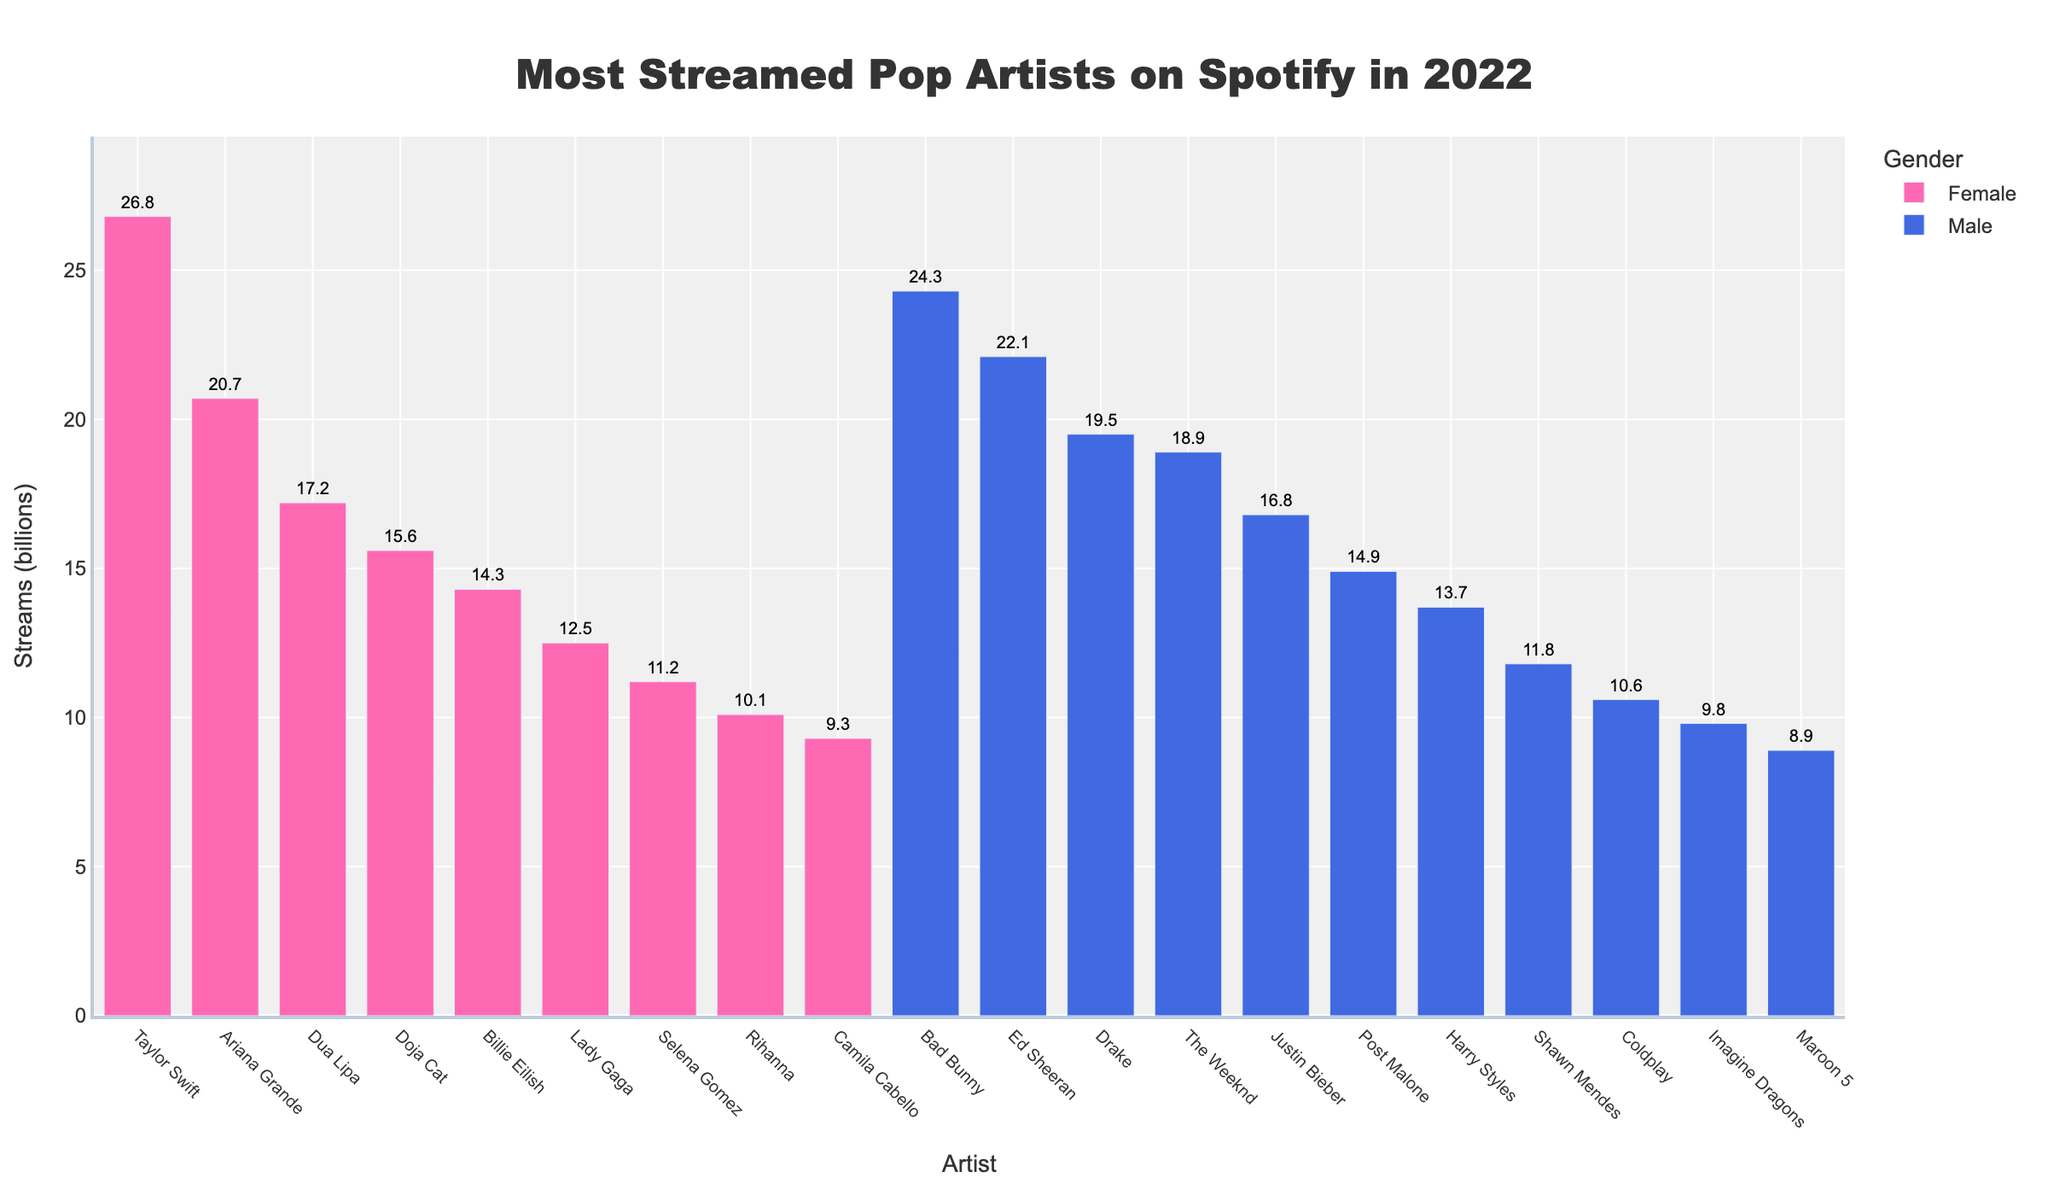Who is the most streamed pop artist on Spotify in 2022? Taylor Swift has the highest bar on the chart with 26.8 billion streams, making her the most streamed artist.
Answer: Taylor Swift Which gender has the highest total streams? Summing the streams for each gender, females have significant contributions (Taylor Swift: 26.8, Ariana Grande: 20.7, etc.), while males also have substantial streams (Bad Bunny: 24.3, Ed Sheeran: 22.1, etc.). However, combining all artists, males collectively have higher total streams.
Answer: Male Who has more streams, Ed Sheeran or Ariana Grande? Both streams can be directly compared from the chart, where Ed Sheeran (22.1 billion) surpasses Ariana Grande (20.7 billion).
Answer: Ed Sheeran How many female artists are in the top 10 most streamed list? Observing the top 10 artists, there are 5 female artists: Taylor Swift, Ariana Grande, Dua Lipa, Doja Cat, and Billie Eilish.
Answer: 5 What is the total number of streams for female artists in the chart? Adding the streams for all listed female artists: 26.8 (Taylor Swift) + 20.7 (Ariana Grande) + 17.2 (Dua Lipa) + 15.6 (Doja Cat) + 14.3 (Billie Eilish) + 12.5 (Lady Gaga) + 11.2 (Selena Gomez) + 10.1 (Rihanna) + 9.3 (Camila Cabello) = 127.7 billion.
Answer: 127.7 billion Who are the top 3 male artists with the most streams? Based on the bar heights and numerical labels, the top 3 male artists with the most streams are Bad Bunny (24.3 billion), Ed Sheeran (22.1 billion), and Drake (19.5 billion).
Answer: Bad Bunny, Ed Sheeran, Drake Which artist has the least streams among the listed ones? From the chart, Maroon 5 is at the bottom with 8.9 billion streams, making them the least streamed artist on the list.
Answer: Maroon 5 What is the stream difference between Bad Bunny and Justin Bieber? Subtracting Justin Bieber’s streams (16.8 billion) from Bad Bunny’s streams (24.3 billion) gives the difference: 24.3 - 16.8 = 7.5 billion streams.
Answer: 7.5 billion Who has more streams, Billie Eilish or The Weeknd? Comparing the chart bars or figures, The Weeknd has higher streams (18.9 billion) than Billie Eilish (14.3 billion).
Answer: The Weeknd What is the average stream count for the top 5 most streamed artists? Summing the streams of the top 5 artists: 26.8 (Taylor Swift) + 24.3 (Bad Bunny) + 22.1 (Ed Sheeran) + 20.7 (Ariana Grande) + 19.5 (Drake) = 113.4 billion, and dividing by 5, the average is 113.4 / 5 = 22.68 billion streams.
Answer: 22.68 billion 